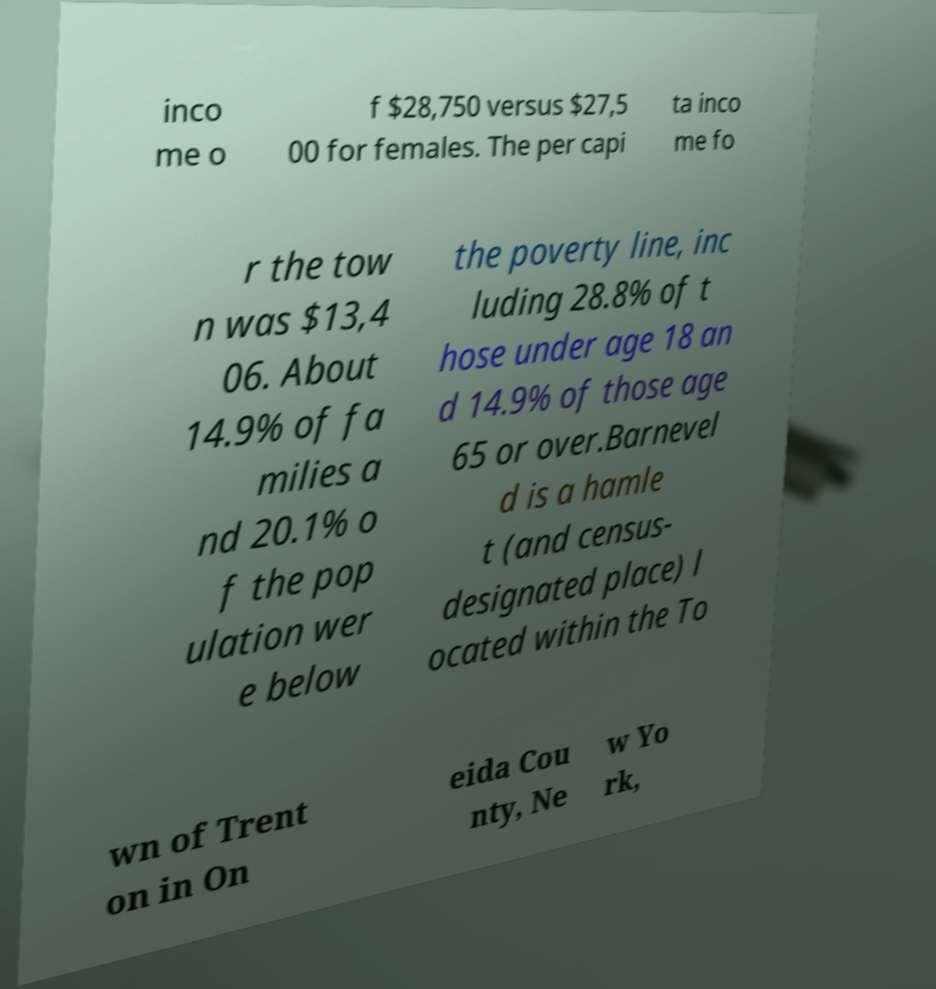Could you assist in decoding the text presented in this image and type it out clearly? inco me o f $28,750 versus $27,5 00 for females. The per capi ta inco me fo r the tow n was $13,4 06. About 14.9% of fa milies a nd 20.1% o f the pop ulation wer e below the poverty line, inc luding 28.8% of t hose under age 18 an d 14.9% of those age 65 or over.Barnevel d is a hamle t (and census- designated place) l ocated within the To wn of Trent on in On eida Cou nty, Ne w Yo rk, 